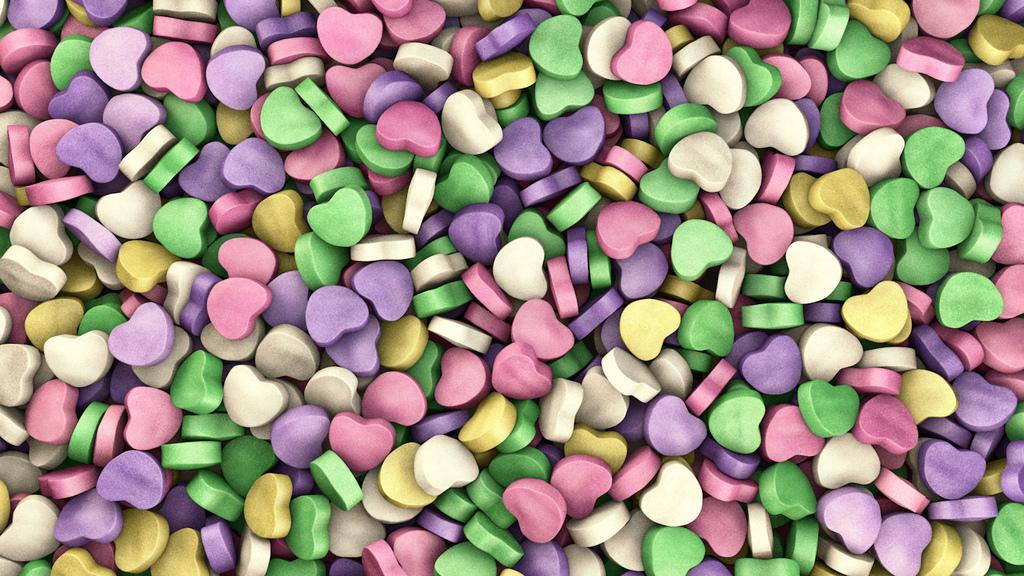What is the shape of the objects in the image? The objects in the image are heart-shaped. What can be said about the color of the objects? The heart-shaped objects in the image are colorful. What type of can is visible in the image? There is no can present in the image; it only features heart-shaped colorful objects. 